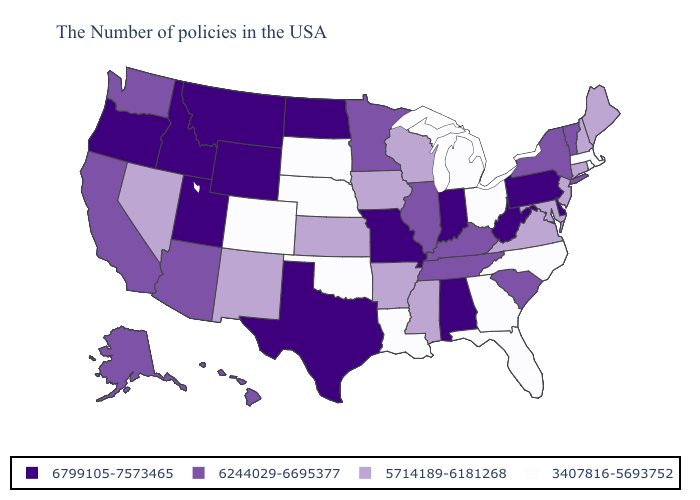What is the value of New Mexico?
Give a very brief answer. 5714189-6181268. Name the states that have a value in the range 3407816-5693752?
Be succinct. Massachusetts, Rhode Island, North Carolina, Ohio, Florida, Georgia, Michigan, Louisiana, Nebraska, Oklahoma, South Dakota, Colorado. What is the highest value in states that border Oklahoma?
Quick response, please. 6799105-7573465. Among the states that border Maryland , which have the highest value?
Keep it brief. Delaware, Pennsylvania, West Virginia. What is the highest value in the MidWest ?
Answer briefly. 6799105-7573465. Name the states that have a value in the range 6244029-6695377?
Answer briefly. Vermont, New York, South Carolina, Kentucky, Tennessee, Illinois, Minnesota, Arizona, California, Washington, Alaska, Hawaii. Name the states that have a value in the range 6799105-7573465?
Short answer required. Delaware, Pennsylvania, West Virginia, Indiana, Alabama, Missouri, Texas, North Dakota, Wyoming, Utah, Montana, Idaho, Oregon. Does Texas have the same value as Massachusetts?
Short answer required. No. Among the states that border Kansas , which have the highest value?
Quick response, please. Missouri. What is the highest value in the USA?
Answer briefly. 6799105-7573465. Among the states that border New Jersey , which have the lowest value?
Short answer required. New York. What is the value of Michigan?
Keep it brief. 3407816-5693752. Does California have the lowest value in the USA?
Answer briefly. No. What is the value of Arkansas?
Write a very short answer. 5714189-6181268. What is the value of Louisiana?
Short answer required. 3407816-5693752. 